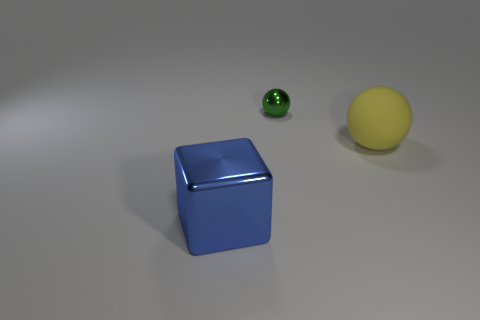Are there any other things that have the same size as the green ball?
Ensure brevity in your answer.  No. Are there any other things that have the same shape as the large metallic thing?
Your answer should be very brief. No. Are there fewer big balls than things?
Keep it short and to the point. Yes. What is the material of the object that is both to the left of the rubber sphere and in front of the green shiny thing?
Offer a terse response. Metal. There is a object that is in front of the big matte thing; is there a metallic thing that is right of it?
Offer a terse response. Yes. What number of things are either yellow objects or small green things?
Offer a very short reply. 2. There is a object that is both in front of the tiny green metal thing and behind the large shiny block; what shape is it?
Make the answer very short. Sphere. Is the material of the big object to the left of the tiny shiny sphere the same as the green object?
Offer a terse response. Yes. How many objects are either large shiny blocks or metal objects that are on the left side of the metallic ball?
Make the answer very short. 1. There is a ball that is made of the same material as the block; what color is it?
Make the answer very short. Green. 